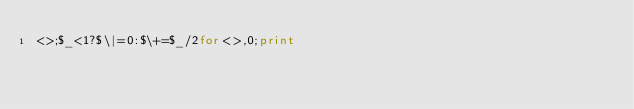<code> <loc_0><loc_0><loc_500><loc_500><_Perl_><>;$_<1?$\|=0:$\+=$_/2for<>,0;print</code> 